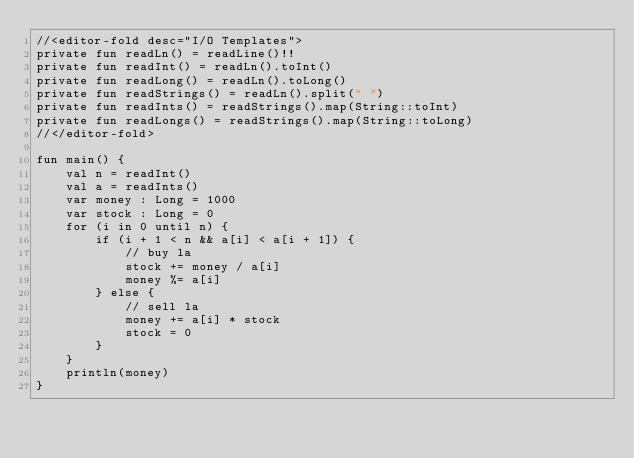<code> <loc_0><loc_0><loc_500><loc_500><_Kotlin_>//<editor-fold desc="I/O Templates">
private fun readLn() = readLine()!!
private fun readInt() = readLn().toInt()
private fun readLong() = readLn().toLong()
private fun readStrings() = readLn().split(" ")
private fun readInts() = readStrings().map(String::toInt)
private fun readLongs() = readStrings().map(String::toLong)
//</editor-fold>

fun main() {
    val n = readInt()
    val a = readInts()
    var money : Long = 1000
    var stock : Long = 0
    for (i in 0 until n) {
        if (i + 1 < n && a[i] < a[i + 1]) {
            // buy la
            stock += money / a[i]
            money %= a[i]
        } else {
            // sell la
            money += a[i] * stock
            stock = 0
        }
    }
    println(money)
}</code> 